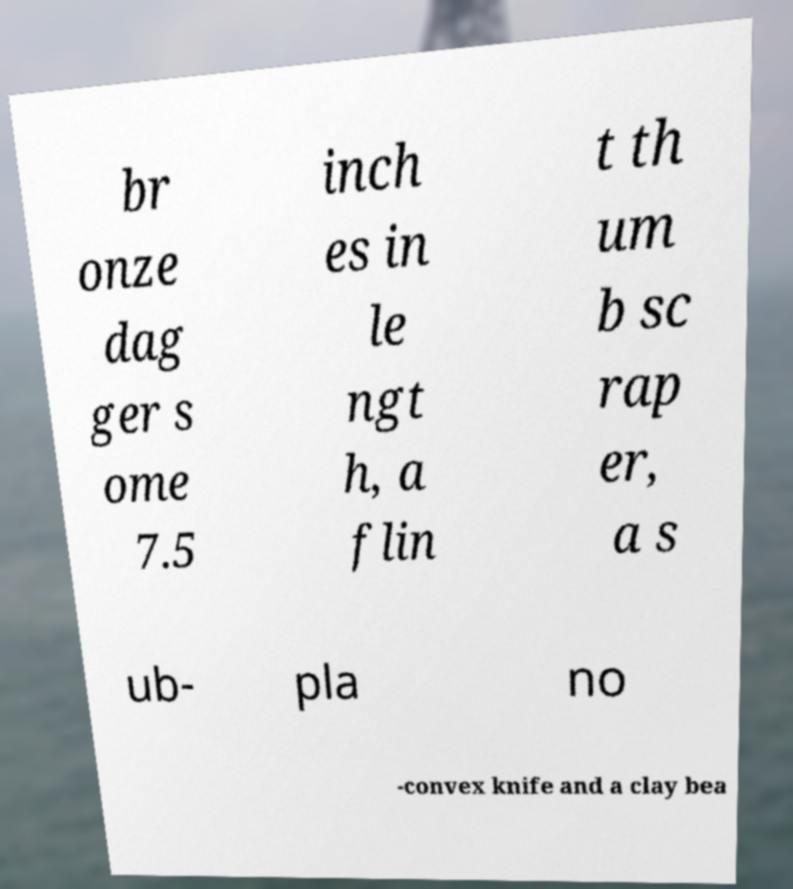Please read and relay the text visible in this image. What does it say? br onze dag ger s ome 7.5 inch es in le ngt h, a flin t th um b sc rap er, a s ub- pla no -convex knife and a clay bea 